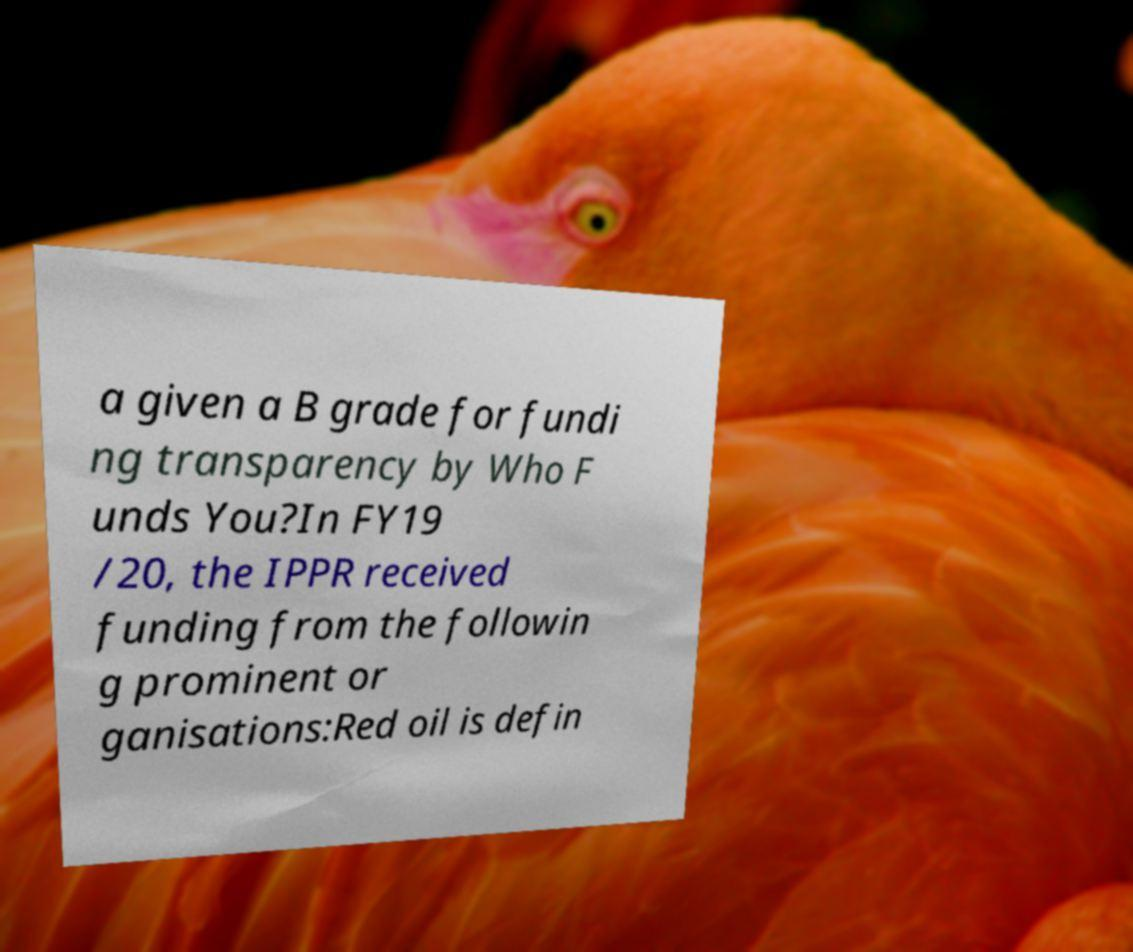There's text embedded in this image that I need extracted. Can you transcribe it verbatim? a given a B grade for fundi ng transparency by Who F unds You?In FY19 /20, the IPPR received funding from the followin g prominent or ganisations:Red oil is defin 